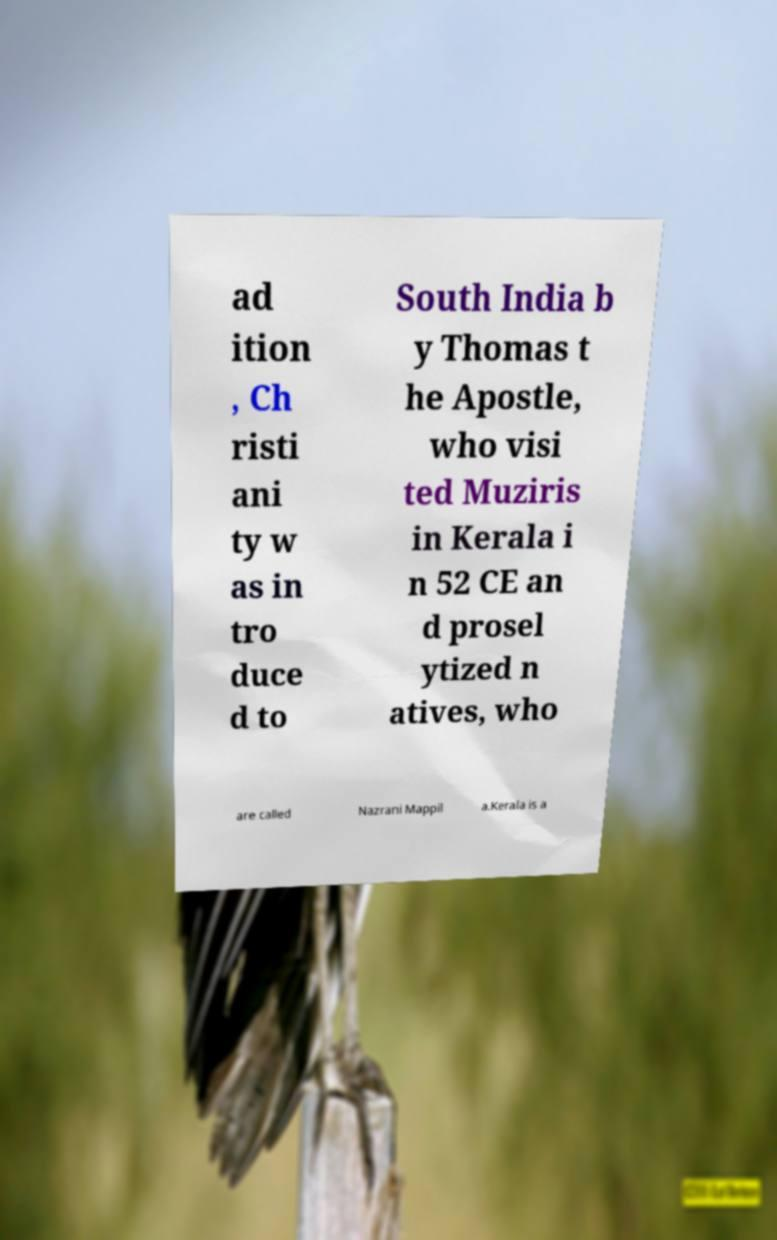What messages or text are displayed in this image? I need them in a readable, typed format. ad ition , Ch risti ani ty w as in tro duce d to South India b y Thomas t he Apostle, who visi ted Muziris in Kerala i n 52 CE an d prosel ytized n atives, who are called Nazrani Mappil a.Kerala is a 